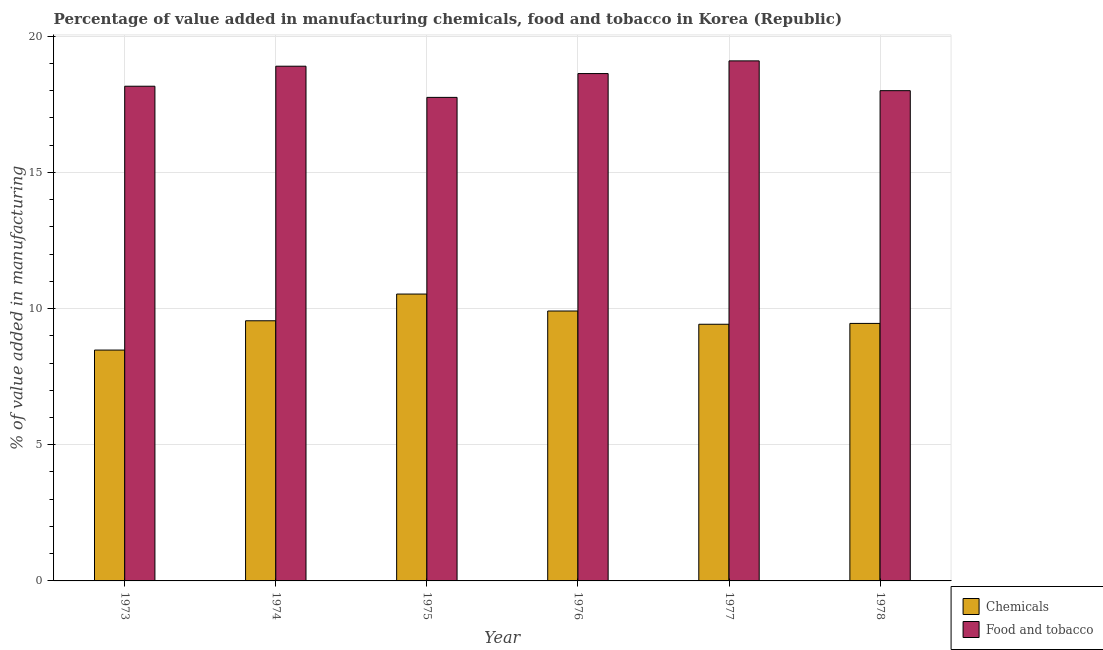How many different coloured bars are there?
Provide a succinct answer. 2. How many groups of bars are there?
Your answer should be very brief. 6. Are the number of bars per tick equal to the number of legend labels?
Provide a succinct answer. Yes. Are the number of bars on each tick of the X-axis equal?
Provide a short and direct response. Yes. How many bars are there on the 2nd tick from the left?
Provide a short and direct response. 2. How many bars are there on the 2nd tick from the right?
Your answer should be very brief. 2. What is the label of the 6th group of bars from the left?
Ensure brevity in your answer.  1978. What is the value added by manufacturing food and tobacco in 1976?
Provide a short and direct response. 18.63. Across all years, what is the maximum value added by  manufacturing chemicals?
Provide a succinct answer. 10.53. Across all years, what is the minimum value added by manufacturing food and tobacco?
Your response must be concise. 17.76. In which year was the value added by  manufacturing chemicals maximum?
Your answer should be very brief. 1975. What is the total value added by  manufacturing chemicals in the graph?
Give a very brief answer. 57.36. What is the difference between the value added by manufacturing food and tobacco in 1975 and that in 1978?
Provide a short and direct response. -0.25. What is the difference between the value added by manufacturing food and tobacco in 1977 and the value added by  manufacturing chemicals in 1974?
Keep it short and to the point. 0.2. What is the average value added by manufacturing food and tobacco per year?
Offer a very short reply. 18.43. What is the ratio of the value added by manufacturing food and tobacco in 1974 to that in 1978?
Provide a short and direct response. 1.05. Is the value added by manufacturing food and tobacco in 1973 less than that in 1978?
Offer a very short reply. No. What is the difference between the highest and the second highest value added by  manufacturing chemicals?
Offer a very short reply. 0.62. What is the difference between the highest and the lowest value added by manufacturing food and tobacco?
Keep it short and to the point. 1.34. What does the 2nd bar from the left in 1973 represents?
Ensure brevity in your answer.  Food and tobacco. What does the 1st bar from the right in 1976 represents?
Your answer should be very brief. Food and tobacco. How many bars are there?
Your answer should be compact. 12. How many years are there in the graph?
Give a very brief answer. 6. What is the difference between two consecutive major ticks on the Y-axis?
Your answer should be compact. 5. Are the values on the major ticks of Y-axis written in scientific E-notation?
Your response must be concise. No. How are the legend labels stacked?
Provide a short and direct response. Vertical. What is the title of the graph?
Give a very brief answer. Percentage of value added in manufacturing chemicals, food and tobacco in Korea (Republic). What is the label or title of the X-axis?
Your response must be concise. Year. What is the label or title of the Y-axis?
Give a very brief answer. % of value added in manufacturing. What is the % of value added in manufacturing in Chemicals in 1973?
Your response must be concise. 8.48. What is the % of value added in manufacturing of Food and tobacco in 1973?
Give a very brief answer. 18.17. What is the % of value added in manufacturing of Chemicals in 1974?
Offer a very short reply. 9.55. What is the % of value added in manufacturing of Food and tobacco in 1974?
Ensure brevity in your answer.  18.9. What is the % of value added in manufacturing in Chemicals in 1975?
Give a very brief answer. 10.53. What is the % of value added in manufacturing of Food and tobacco in 1975?
Offer a very short reply. 17.76. What is the % of value added in manufacturing of Chemicals in 1976?
Keep it short and to the point. 9.91. What is the % of value added in manufacturing of Food and tobacco in 1976?
Your answer should be compact. 18.63. What is the % of value added in manufacturing in Chemicals in 1977?
Your answer should be very brief. 9.42. What is the % of value added in manufacturing in Food and tobacco in 1977?
Make the answer very short. 19.1. What is the % of value added in manufacturing of Chemicals in 1978?
Provide a succinct answer. 9.46. What is the % of value added in manufacturing in Food and tobacco in 1978?
Offer a terse response. 18. Across all years, what is the maximum % of value added in manufacturing of Chemicals?
Give a very brief answer. 10.53. Across all years, what is the maximum % of value added in manufacturing of Food and tobacco?
Keep it short and to the point. 19.1. Across all years, what is the minimum % of value added in manufacturing in Chemicals?
Provide a short and direct response. 8.48. Across all years, what is the minimum % of value added in manufacturing in Food and tobacco?
Ensure brevity in your answer.  17.76. What is the total % of value added in manufacturing of Chemicals in the graph?
Your response must be concise. 57.36. What is the total % of value added in manufacturing in Food and tobacco in the graph?
Provide a short and direct response. 110.55. What is the difference between the % of value added in manufacturing of Chemicals in 1973 and that in 1974?
Ensure brevity in your answer.  -1.08. What is the difference between the % of value added in manufacturing in Food and tobacco in 1973 and that in 1974?
Provide a succinct answer. -0.74. What is the difference between the % of value added in manufacturing in Chemicals in 1973 and that in 1975?
Provide a short and direct response. -2.06. What is the difference between the % of value added in manufacturing of Food and tobacco in 1973 and that in 1975?
Provide a short and direct response. 0.41. What is the difference between the % of value added in manufacturing in Chemicals in 1973 and that in 1976?
Ensure brevity in your answer.  -1.43. What is the difference between the % of value added in manufacturing in Food and tobacco in 1973 and that in 1976?
Your answer should be very brief. -0.46. What is the difference between the % of value added in manufacturing of Chemicals in 1973 and that in 1977?
Offer a terse response. -0.95. What is the difference between the % of value added in manufacturing of Food and tobacco in 1973 and that in 1977?
Your response must be concise. -0.93. What is the difference between the % of value added in manufacturing in Chemicals in 1973 and that in 1978?
Your response must be concise. -0.98. What is the difference between the % of value added in manufacturing in Food and tobacco in 1973 and that in 1978?
Your response must be concise. 0.16. What is the difference between the % of value added in manufacturing in Chemicals in 1974 and that in 1975?
Make the answer very short. -0.98. What is the difference between the % of value added in manufacturing in Food and tobacco in 1974 and that in 1975?
Your response must be concise. 1.14. What is the difference between the % of value added in manufacturing in Chemicals in 1974 and that in 1976?
Give a very brief answer. -0.36. What is the difference between the % of value added in manufacturing in Food and tobacco in 1974 and that in 1976?
Offer a very short reply. 0.27. What is the difference between the % of value added in manufacturing in Chemicals in 1974 and that in 1977?
Offer a very short reply. 0.13. What is the difference between the % of value added in manufacturing in Food and tobacco in 1974 and that in 1977?
Offer a terse response. -0.2. What is the difference between the % of value added in manufacturing of Chemicals in 1974 and that in 1978?
Ensure brevity in your answer.  0.1. What is the difference between the % of value added in manufacturing of Food and tobacco in 1974 and that in 1978?
Your answer should be compact. 0.9. What is the difference between the % of value added in manufacturing in Chemicals in 1975 and that in 1976?
Keep it short and to the point. 0.62. What is the difference between the % of value added in manufacturing of Food and tobacco in 1975 and that in 1976?
Your answer should be compact. -0.87. What is the difference between the % of value added in manufacturing in Chemicals in 1975 and that in 1977?
Make the answer very short. 1.11. What is the difference between the % of value added in manufacturing of Food and tobacco in 1975 and that in 1977?
Your answer should be compact. -1.34. What is the difference between the % of value added in manufacturing in Chemicals in 1975 and that in 1978?
Provide a succinct answer. 1.08. What is the difference between the % of value added in manufacturing in Food and tobacco in 1975 and that in 1978?
Your answer should be compact. -0.25. What is the difference between the % of value added in manufacturing in Chemicals in 1976 and that in 1977?
Your response must be concise. 0.49. What is the difference between the % of value added in manufacturing of Food and tobacco in 1976 and that in 1977?
Provide a succinct answer. -0.47. What is the difference between the % of value added in manufacturing of Chemicals in 1976 and that in 1978?
Offer a very short reply. 0.46. What is the difference between the % of value added in manufacturing of Food and tobacco in 1976 and that in 1978?
Offer a very short reply. 0.63. What is the difference between the % of value added in manufacturing in Chemicals in 1977 and that in 1978?
Offer a terse response. -0.03. What is the difference between the % of value added in manufacturing in Food and tobacco in 1977 and that in 1978?
Offer a very short reply. 1.09. What is the difference between the % of value added in manufacturing of Chemicals in 1973 and the % of value added in manufacturing of Food and tobacco in 1974?
Provide a succinct answer. -10.42. What is the difference between the % of value added in manufacturing of Chemicals in 1973 and the % of value added in manufacturing of Food and tobacco in 1975?
Make the answer very short. -9.28. What is the difference between the % of value added in manufacturing in Chemicals in 1973 and the % of value added in manufacturing in Food and tobacco in 1976?
Make the answer very short. -10.15. What is the difference between the % of value added in manufacturing of Chemicals in 1973 and the % of value added in manufacturing of Food and tobacco in 1977?
Offer a very short reply. -10.62. What is the difference between the % of value added in manufacturing of Chemicals in 1973 and the % of value added in manufacturing of Food and tobacco in 1978?
Offer a very short reply. -9.53. What is the difference between the % of value added in manufacturing in Chemicals in 1974 and the % of value added in manufacturing in Food and tobacco in 1975?
Your answer should be very brief. -8.2. What is the difference between the % of value added in manufacturing in Chemicals in 1974 and the % of value added in manufacturing in Food and tobacco in 1976?
Give a very brief answer. -9.08. What is the difference between the % of value added in manufacturing in Chemicals in 1974 and the % of value added in manufacturing in Food and tobacco in 1977?
Give a very brief answer. -9.54. What is the difference between the % of value added in manufacturing in Chemicals in 1974 and the % of value added in manufacturing in Food and tobacco in 1978?
Ensure brevity in your answer.  -8.45. What is the difference between the % of value added in manufacturing in Chemicals in 1975 and the % of value added in manufacturing in Food and tobacco in 1976?
Offer a very short reply. -8.1. What is the difference between the % of value added in manufacturing of Chemicals in 1975 and the % of value added in manufacturing of Food and tobacco in 1977?
Give a very brief answer. -8.56. What is the difference between the % of value added in manufacturing in Chemicals in 1975 and the % of value added in manufacturing in Food and tobacco in 1978?
Keep it short and to the point. -7.47. What is the difference between the % of value added in manufacturing in Chemicals in 1976 and the % of value added in manufacturing in Food and tobacco in 1977?
Give a very brief answer. -9.18. What is the difference between the % of value added in manufacturing of Chemicals in 1976 and the % of value added in manufacturing of Food and tobacco in 1978?
Provide a succinct answer. -8.09. What is the difference between the % of value added in manufacturing in Chemicals in 1977 and the % of value added in manufacturing in Food and tobacco in 1978?
Give a very brief answer. -8.58. What is the average % of value added in manufacturing in Chemicals per year?
Make the answer very short. 9.56. What is the average % of value added in manufacturing of Food and tobacco per year?
Offer a terse response. 18.43. In the year 1973, what is the difference between the % of value added in manufacturing of Chemicals and % of value added in manufacturing of Food and tobacco?
Offer a very short reply. -9.69. In the year 1974, what is the difference between the % of value added in manufacturing in Chemicals and % of value added in manufacturing in Food and tobacco?
Make the answer very short. -9.35. In the year 1975, what is the difference between the % of value added in manufacturing of Chemicals and % of value added in manufacturing of Food and tobacco?
Offer a very short reply. -7.22. In the year 1976, what is the difference between the % of value added in manufacturing of Chemicals and % of value added in manufacturing of Food and tobacco?
Keep it short and to the point. -8.72. In the year 1977, what is the difference between the % of value added in manufacturing in Chemicals and % of value added in manufacturing in Food and tobacco?
Make the answer very short. -9.67. In the year 1978, what is the difference between the % of value added in manufacturing of Chemicals and % of value added in manufacturing of Food and tobacco?
Offer a terse response. -8.55. What is the ratio of the % of value added in manufacturing of Chemicals in 1973 to that in 1974?
Ensure brevity in your answer.  0.89. What is the ratio of the % of value added in manufacturing of Food and tobacco in 1973 to that in 1974?
Your answer should be very brief. 0.96. What is the ratio of the % of value added in manufacturing of Chemicals in 1973 to that in 1975?
Make the answer very short. 0.8. What is the ratio of the % of value added in manufacturing in Food and tobacco in 1973 to that in 1975?
Your response must be concise. 1.02. What is the ratio of the % of value added in manufacturing in Chemicals in 1973 to that in 1976?
Provide a succinct answer. 0.86. What is the ratio of the % of value added in manufacturing in Chemicals in 1973 to that in 1977?
Give a very brief answer. 0.9. What is the ratio of the % of value added in manufacturing in Food and tobacco in 1973 to that in 1977?
Keep it short and to the point. 0.95. What is the ratio of the % of value added in manufacturing of Chemicals in 1973 to that in 1978?
Your answer should be compact. 0.9. What is the ratio of the % of value added in manufacturing of Food and tobacco in 1973 to that in 1978?
Ensure brevity in your answer.  1.01. What is the ratio of the % of value added in manufacturing of Chemicals in 1974 to that in 1975?
Provide a short and direct response. 0.91. What is the ratio of the % of value added in manufacturing in Food and tobacco in 1974 to that in 1975?
Give a very brief answer. 1.06. What is the ratio of the % of value added in manufacturing of Chemicals in 1974 to that in 1976?
Your response must be concise. 0.96. What is the ratio of the % of value added in manufacturing of Food and tobacco in 1974 to that in 1976?
Ensure brevity in your answer.  1.01. What is the ratio of the % of value added in manufacturing in Chemicals in 1974 to that in 1977?
Your response must be concise. 1.01. What is the ratio of the % of value added in manufacturing in Food and tobacco in 1974 to that in 1977?
Your response must be concise. 0.99. What is the ratio of the % of value added in manufacturing in Chemicals in 1974 to that in 1978?
Ensure brevity in your answer.  1.01. What is the ratio of the % of value added in manufacturing of Food and tobacco in 1974 to that in 1978?
Your response must be concise. 1.05. What is the ratio of the % of value added in manufacturing of Chemicals in 1975 to that in 1976?
Ensure brevity in your answer.  1.06. What is the ratio of the % of value added in manufacturing in Food and tobacco in 1975 to that in 1976?
Your answer should be compact. 0.95. What is the ratio of the % of value added in manufacturing of Chemicals in 1975 to that in 1977?
Keep it short and to the point. 1.12. What is the ratio of the % of value added in manufacturing of Food and tobacco in 1975 to that in 1977?
Keep it short and to the point. 0.93. What is the ratio of the % of value added in manufacturing of Chemicals in 1975 to that in 1978?
Your response must be concise. 1.11. What is the ratio of the % of value added in manufacturing of Food and tobacco in 1975 to that in 1978?
Give a very brief answer. 0.99. What is the ratio of the % of value added in manufacturing in Chemicals in 1976 to that in 1977?
Give a very brief answer. 1.05. What is the ratio of the % of value added in manufacturing in Food and tobacco in 1976 to that in 1977?
Offer a very short reply. 0.98. What is the ratio of the % of value added in manufacturing of Chemicals in 1976 to that in 1978?
Make the answer very short. 1.05. What is the ratio of the % of value added in manufacturing of Food and tobacco in 1976 to that in 1978?
Keep it short and to the point. 1.03. What is the ratio of the % of value added in manufacturing in Chemicals in 1977 to that in 1978?
Provide a succinct answer. 1. What is the ratio of the % of value added in manufacturing in Food and tobacco in 1977 to that in 1978?
Offer a very short reply. 1.06. What is the difference between the highest and the second highest % of value added in manufacturing in Chemicals?
Provide a short and direct response. 0.62. What is the difference between the highest and the second highest % of value added in manufacturing of Food and tobacco?
Give a very brief answer. 0.2. What is the difference between the highest and the lowest % of value added in manufacturing in Chemicals?
Your answer should be compact. 2.06. What is the difference between the highest and the lowest % of value added in manufacturing of Food and tobacco?
Your answer should be very brief. 1.34. 